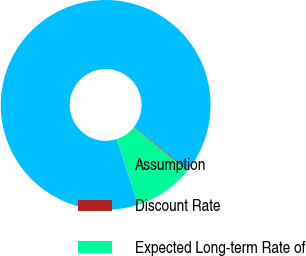Convert chart. <chart><loc_0><loc_0><loc_500><loc_500><pie_chart><fcel>Assumption<fcel>Discount Rate<fcel>Expected Long-term Rate of<nl><fcel>90.62%<fcel>0.17%<fcel>9.21%<nl></chart> 